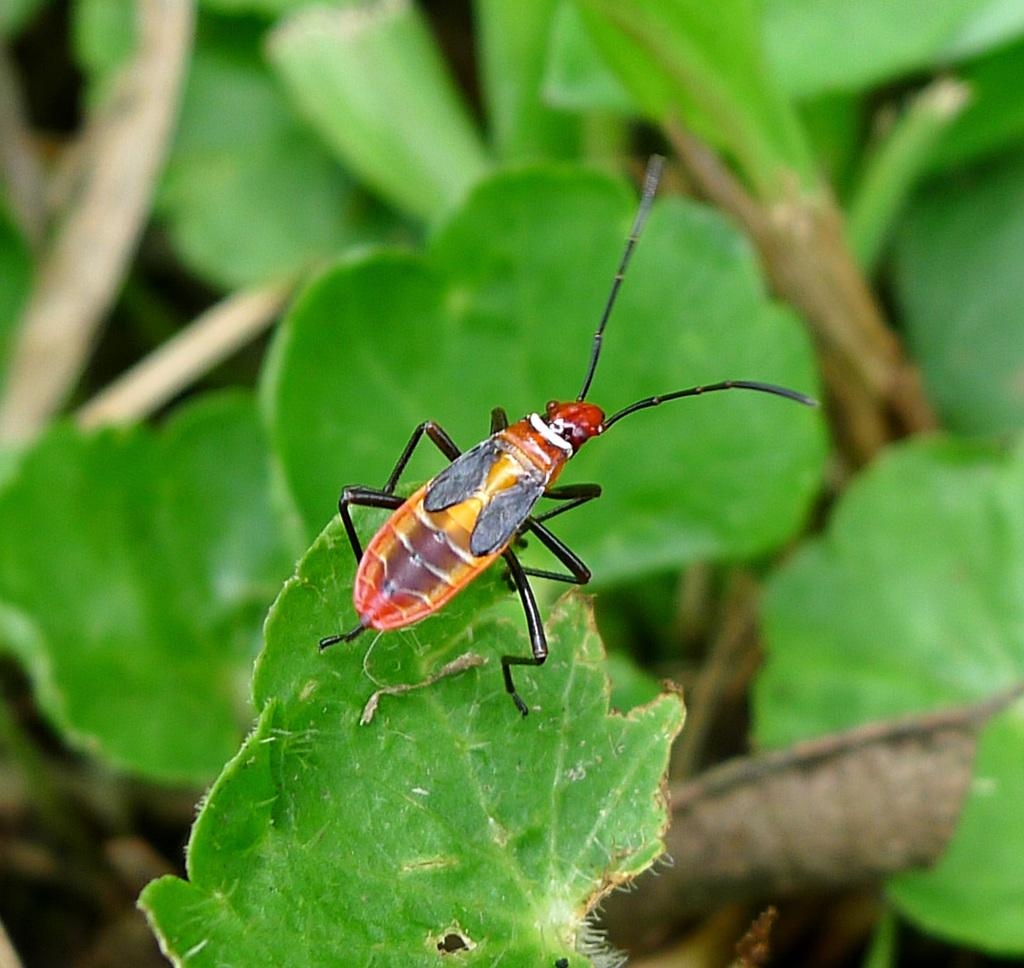What type of living organisms can be seen in the image? Plants and an insect are visible in the image. Can you describe the insect in the image? Unfortunately, the facts provided do not give enough detail to describe the insect. However, we can confirm that there is an insect present. How many children are playing with the yoke in the image? There are no children or yokes present in the image. What type of card game are the children playing with the spade in the image? There are no children or card games present in the image. 